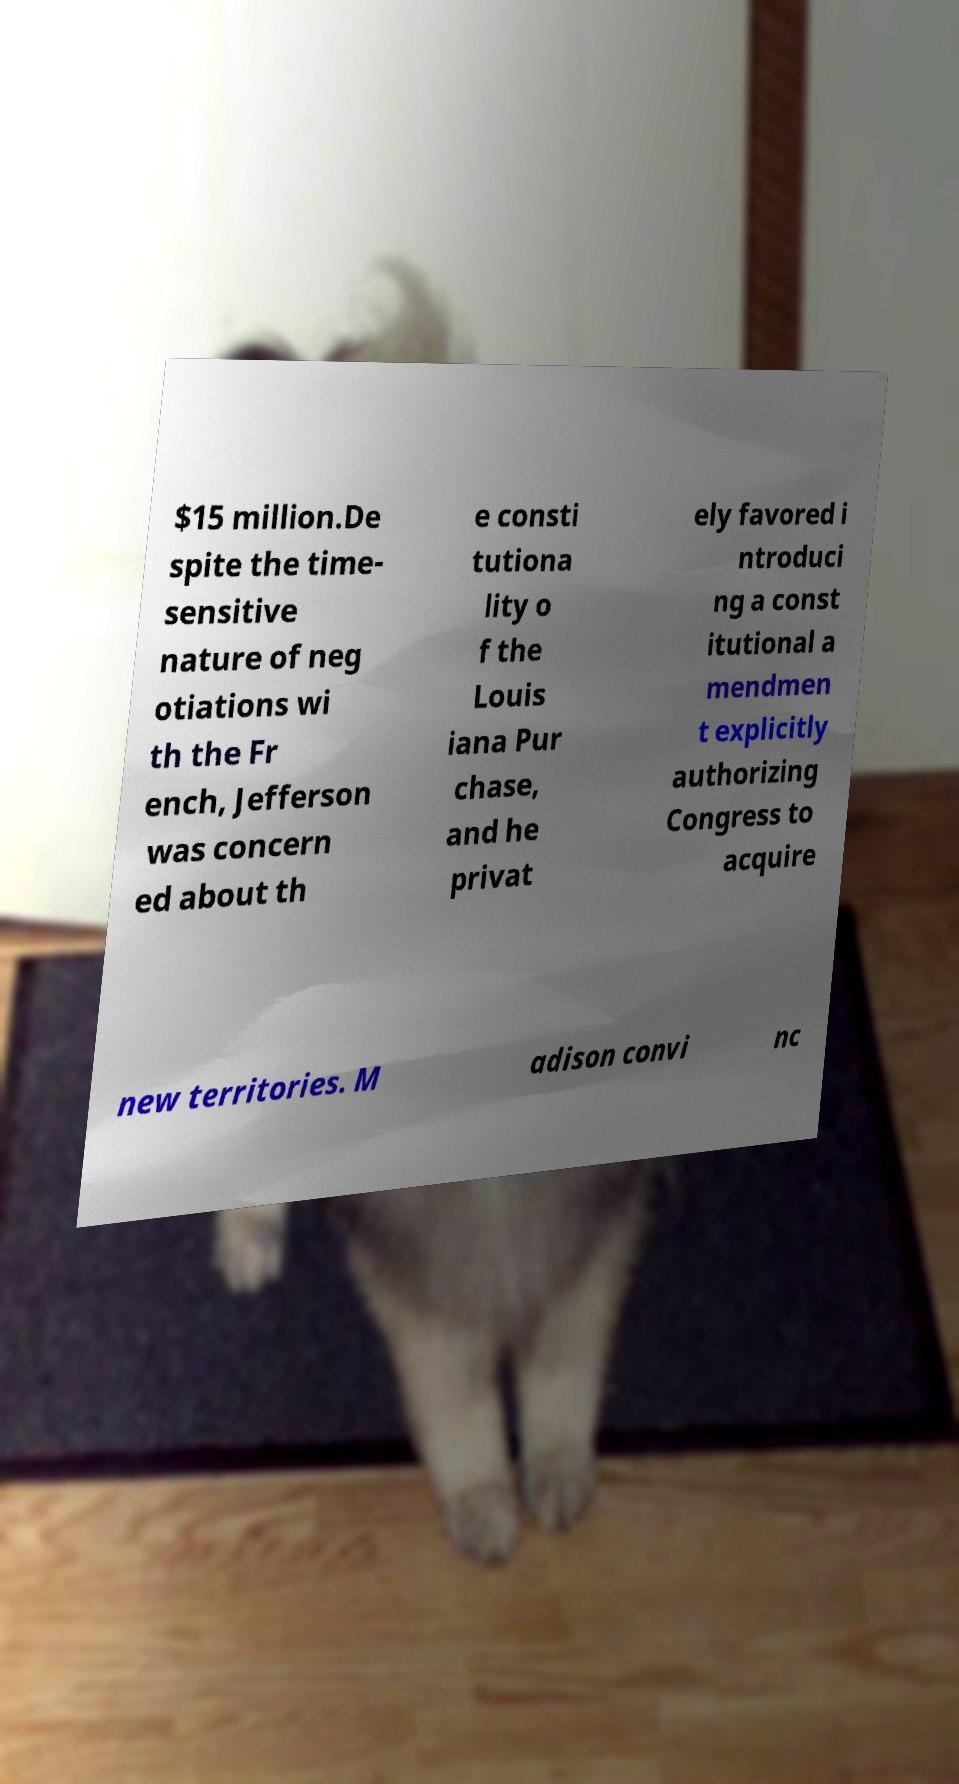I need the written content from this picture converted into text. Can you do that? $15 million.De spite the time- sensitive nature of neg otiations wi th the Fr ench, Jefferson was concern ed about th e consti tutiona lity o f the Louis iana Pur chase, and he privat ely favored i ntroduci ng a const itutional a mendmen t explicitly authorizing Congress to acquire new territories. M adison convi nc 